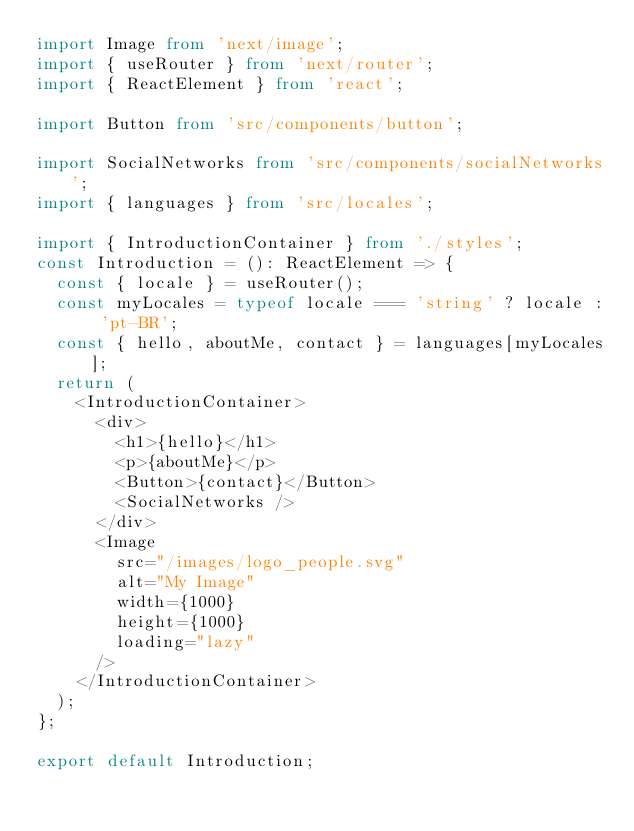<code> <loc_0><loc_0><loc_500><loc_500><_TypeScript_>import Image from 'next/image';
import { useRouter } from 'next/router';
import { ReactElement } from 'react';

import Button from 'src/components/button';

import SocialNetworks from 'src/components/socialNetworks';
import { languages } from 'src/locales';

import { IntroductionContainer } from './styles';
const Introduction = (): ReactElement => {
  const { locale } = useRouter();
  const myLocales = typeof locale === 'string' ? locale : 'pt-BR';
  const { hello, aboutMe, contact } = languages[myLocales];
  return (
    <IntroductionContainer>
      <div>
        <h1>{hello}</h1>
        <p>{aboutMe}</p>
        <Button>{contact}</Button>
        <SocialNetworks />
      </div>
      <Image
        src="/images/logo_people.svg"
        alt="My Image"
        width={1000}
        height={1000}
        loading="lazy"
      />
    </IntroductionContainer>
  );
};

export default Introduction;
</code> 